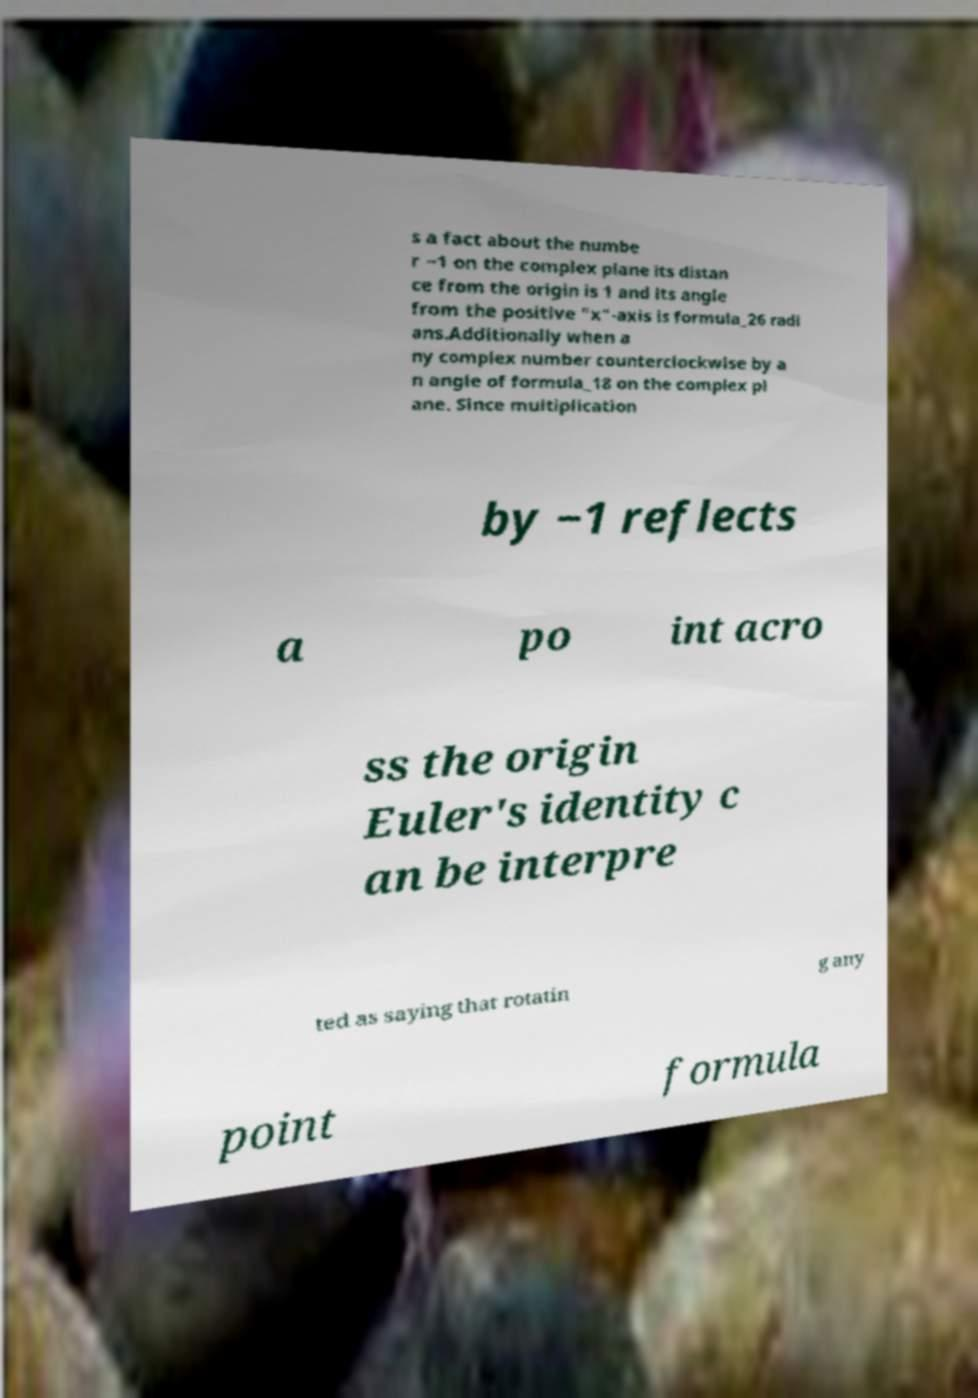I need the written content from this picture converted into text. Can you do that? s a fact about the numbe r −1 on the complex plane its distan ce from the origin is 1 and its angle from the positive "x"-axis is formula_26 radi ans.Additionally when a ny complex number counterclockwise by a n angle of formula_18 on the complex pl ane. Since multiplication by −1 reflects a po int acro ss the origin Euler's identity c an be interpre ted as saying that rotatin g any point formula 